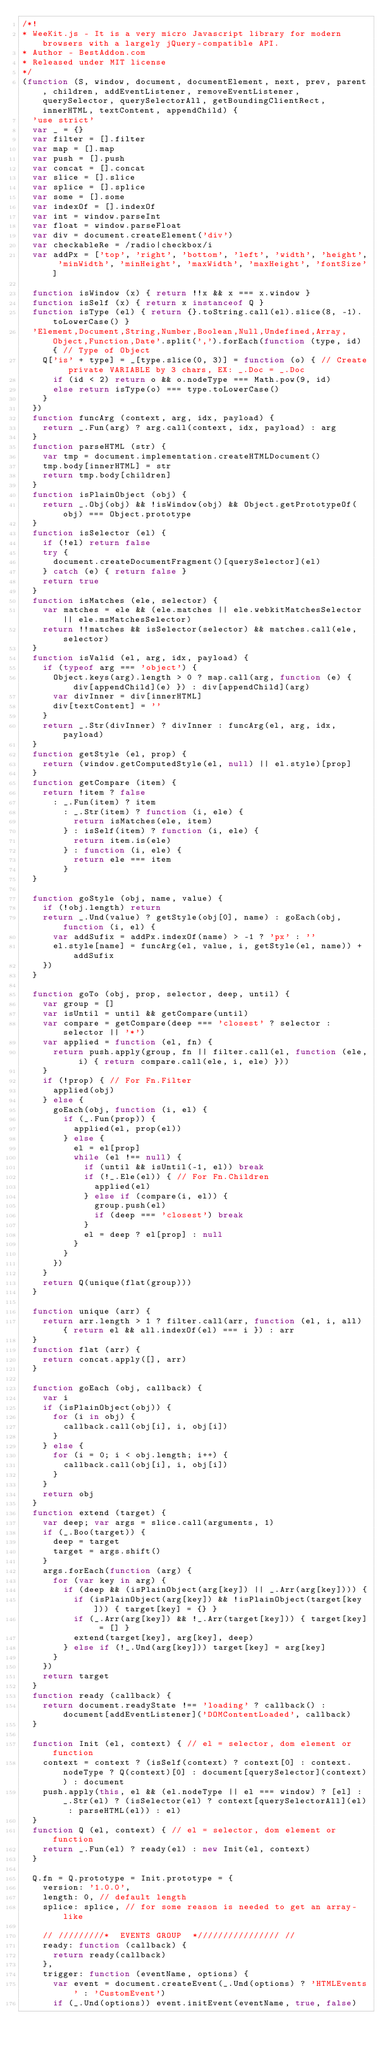Convert code to text. <code><loc_0><loc_0><loc_500><loc_500><_JavaScript_>/*!
* WeeKit.js - It is a very micro Javascript library for modern browsers with a largely jQuery-compatible API.
* Author - BestAddon.com
* Released under MIT license
*/
(function (S, window, document, documentElement, next, prev, parent, children, addEventListener, removeEventListener, querySelector, querySelectorAll, getBoundingClientRect, innerHTML, textContent, appendChild) {
  'use strict'
  var _ = {}
  var filter = [].filter
  var map = [].map
  var push = [].push
  var concat = [].concat
  var slice = [].slice
  var splice = [].splice
  var some = [].some
  var indexOf = [].indexOf
  var int = window.parseInt
  var float = window.parseFloat
  var div = document.createElement('div')
  var checkableRe = /radio|checkbox/i
  var addPx = ['top', 'right', 'bottom', 'left', 'width', 'height', 'minWidth', 'minHeight', 'maxWidth', 'maxHeight', 'fontSize']

  function isWindow (x) { return !!x && x === x.window }
  function isSelf (x) { return x instanceof Q }
  function isType (el) { return {}.toString.call(el).slice(8, -1).toLowerCase() }
  'Element,Document,String,Number,Boolean,Null,Undefined,Array,Object,Function,Date'.split(',').forEach(function (type, id) { // Type of Object
    Q['is' + type] = _[type.slice(0, 3)] = function (o) { // Create private VARIABLE by 3 chars, EX: _.Doc = _.Doc
      if (id < 2) return o && o.nodeType === Math.pow(9, id)
      else return isType(o) === type.toLowerCase()
    }
  })
  function funcArg (context, arg, idx, payload) {
    return _.Fun(arg) ? arg.call(context, idx, payload) : arg
  }
  function parseHTML (str) {
    var tmp = document.implementation.createHTMLDocument()
    tmp.body[innerHTML] = str
    return tmp.body[children]
  }
  function isPlainObject (obj) {
    return _.Obj(obj) && !isWindow(obj) && Object.getPrototypeOf(obj) === Object.prototype
  }
  function isSelector (el) {
    if (!el) return false
    try {
      document.createDocumentFragment()[querySelector](el)
    } catch (e) { return false }
    return true
  }
  function isMatches (ele, selector) {
    var matches = ele && (ele.matches || ele.webkitMatchesSelector || ele.msMatchesSelector)
    return !!matches && isSelector(selector) && matches.call(ele, selector)
  }
  function isValid (el, arg, idx, payload) {
    if (typeof arg === 'object') {
      Object.keys(arg).length > 0 ? map.call(arg, function (e) { div[appendChild](e) }) : div[appendChild](arg)
      var divInner = div[innerHTML]
      div[textContent] = ''
    }
    return _.Str(divInner) ? divInner : funcArg(el, arg, idx, payload)
  }
  function getStyle (el, prop) {
    return (window.getComputedStyle(el, null) || el.style)[prop]
  }
  function getCompare (item) {
    return !item ? false
      : _.Fun(item) ? item
        : _.Str(item) ? function (i, ele) {
          return isMatches(ele, item)
        } : isSelf(item) ? function (i, ele) {
          return item.is(ele)
        } : function (i, ele) {
          return ele === item
        }
  }

  function goStyle (obj, name, value) {
    if (!obj.length) return
    return _.Und(value) ? getStyle(obj[0], name) : goEach(obj, function (i, el) {
      var addSufix = addPx.indexOf(name) > -1 ? 'px' : ''
      el.style[name] = funcArg(el, value, i, getStyle(el, name)) + addSufix
    })
  }

  function goTo (obj, prop, selector, deep, until) {
    var group = []
    var isUntil = until && getCompare(until)
    var compare = getCompare(deep === 'closest' ? selector : selector || '*')
    var applied = function (el, fn) {
      return push.apply(group, fn || filter.call(el, function (ele, i) { return compare.call(ele, i, ele) }))
    }
    if (!prop) { // For Fn.Filter
      applied(obj)
    } else {
      goEach(obj, function (i, el) {
        if (_.Fun(prop)) {
          applied(el, prop(el))
        } else {
          el = el[prop]
          while (el !== null) {
            if (until && isUntil(-1, el)) break
            if (!_.Ele(el)) { // For Fn.Children
              applied(el)
            } else if (compare(i, el)) {
              group.push(el)
              if (deep === 'closest') break
            }
            el = deep ? el[prop] : null
          }
        }
      })
    }
    return Q(unique(flat(group)))
  }

  function unique (arr) {
    return arr.length > 1 ? filter.call(arr, function (el, i, all) { return el && all.indexOf(el) === i }) : arr
  }
  function flat (arr) {
    return concat.apply([], arr)
  }

  function goEach (obj, callback) {
    var i
    if (isPlainObject(obj)) {
      for (i in obj) {
        callback.call(obj[i], i, obj[i])
      }
    } else {
      for (i = 0; i < obj.length; i++) {
        callback.call(obj[i], i, obj[i])
      }
    }
    return obj
  }
  function extend (target) {
    var deep; var args = slice.call(arguments, 1)
    if (_.Boo(target)) {
      deep = target
      target = args.shift()
    }
    args.forEach(function (arg) {
      for (var key in arg) {
        if (deep && (isPlainObject(arg[key]) || _.Arr(arg[key]))) {
          if (isPlainObject(arg[key]) && !isPlainObject(target[key])) { target[key] = {} }
          if (_.Arr(arg[key]) && !_.Arr(target[key])) { target[key] = [] }
          extend(target[key], arg[key], deep)
        } else if (!_.Und(arg[key])) target[key] = arg[key]
      }
    })
    return target
  }
  function ready (callback) {
    return document.readyState !== 'loading' ? callback() : document[addEventListener]('DOMContentLoaded', callback)
  }

  function Init (el, context) { // el = selector, dom element or function
    context = context ? (isSelf(context) ? context[0] : context.nodeType ? Q(context)[0] : document[querySelector](context)) : document
    push.apply(this, el && (el.nodeType || el === window) ? [el] : _.Str(el) ? (isSelector(el) ? context[querySelectorAll](el) : parseHTML(el)) : el)
  }
  function Q (el, context) { // el = selector, dom element or function
    return _.Fun(el) ? ready(el) : new Init(el, context)
  }

  Q.fn = Q.prototype = Init.prototype = {
    version: '1.0.0',
    length: 0, // default length
    splice: splice, // for some reason is needed to get an array-like

    // /////////*  EVENTS GROUP  *//////////////// //
    ready: function (callback) {
      return ready(callback)
    },
    trigger: function (eventName, options) {
      var event = document.createEvent(_.Und(options) ? 'HTMLEvents' : 'CustomEvent')
      if (_.Und(options)) event.initEvent(eventName, true, false)</code> 